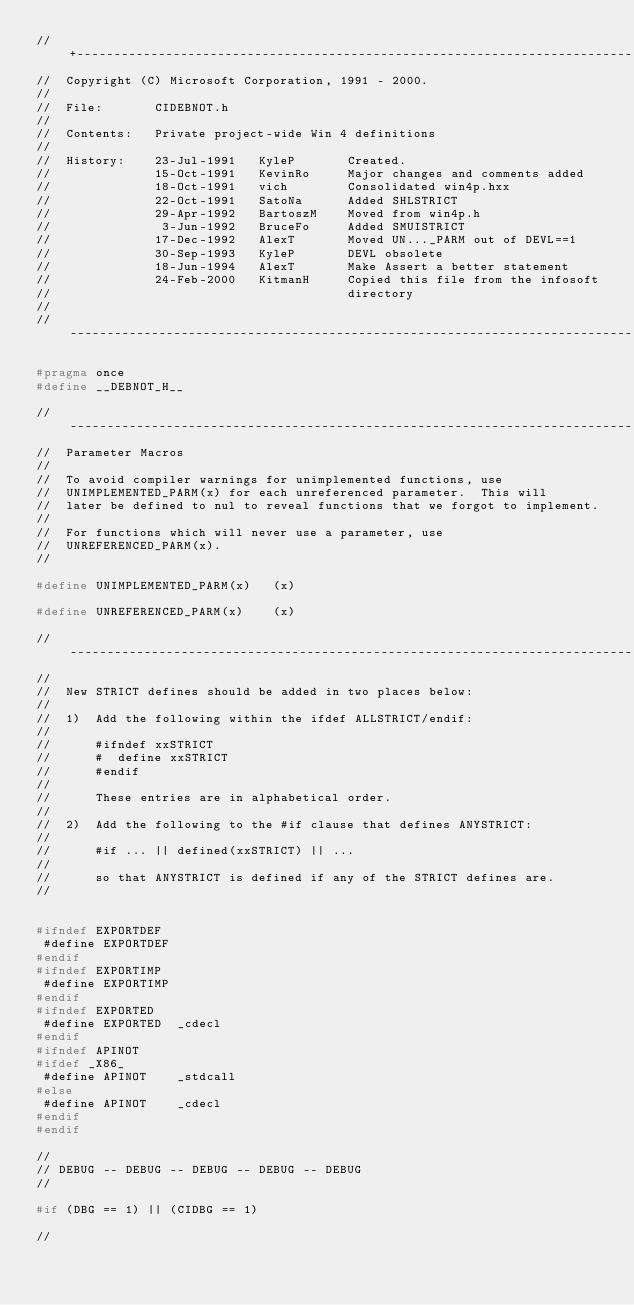<code> <loc_0><loc_0><loc_500><loc_500><_C_>//+---------------------------------------------------------------------------
//  Copyright (C) Microsoft Corporation, 1991 - 2000.
//
//  File:       CIDEBNOT.h
//
//  Contents:   Private project-wide Win 4 definitions
//
//  History:    23-Jul-1991   KyleP       Created.
//              15-Oct-1991   KevinRo     Major changes and comments added
//              18-Oct-1991   vich        Consolidated win4p.hxx
//              22-Oct-1991   SatoNa      Added SHLSTRICT
//              29-Apr-1992   BartoszM    Moved from win4p.h
//               3-Jun-1992   BruceFo     Added SMUISTRICT
//              17-Dec-1992   AlexT       Moved UN..._PARM out of DEVL==1
//              30-Sep-1993   KyleP       DEVL obsolete
//              18-Jun-1994   AlexT       Make Assert a better statement
//              24-Feb-2000   KitmanH     Copied this file from the infosoft 
//                                        directory   
//
//----------------------------------------------------------------------------

#pragma once
#define __DEBNOT_H__

//----------------------------------------------------------------------------
//  Parameter Macros
//
//  To avoid compiler warnings for unimplemented functions, use
//  UNIMPLEMENTED_PARM(x) for each unreferenced parameter.  This will
//  later be defined to nul to reveal functions that we forgot to implement.
//
//  For functions which will never use a parameter, use
//  UNREFERENCED_PARM(x).
//

#define UNIMPLEMENTED_PARM(x)   (x)

#define UNREFERENCED_PARM(x)    (x)

//----------------------------------------------------------------------------
//
//  New STRICT defines should be added in two places below:
//
//  1)  Add the following within the ifdef ALLSTRICT/endif:
//
//      #ifndef xxSTRICT
//      #  define xxSTRICT
//      #endif
//
//      These entries are in alphabetical order.
//
//  2)  Add the following to the #if clause that defines ANYSTRICT:
//
//      #if ... || defined(xxSTRICT) || ...
//
//      so that ANYSTRICT is defined if any of the STRICT defines are.
//


#ifndef EXPORTDEF
 #define EXPORTDEF
#endif
#ifndef EXPORTIMP
 #define EXPORTIMP
#endif
#ifndef EXPORTED
 #define EXPORTED  _cdecl
#endif
#ifndef APINOT
#ifdef _X86_
 #define APINOT    _stdcall
#else
 #define APINOT    _cdecl
#endif
#endif

//
// DEBUG -- DEBUG -- DEBUG -- DEBUG -- DEBUG
//

#if (DBG == 1) || (CIDBG == 1)

//</code> 